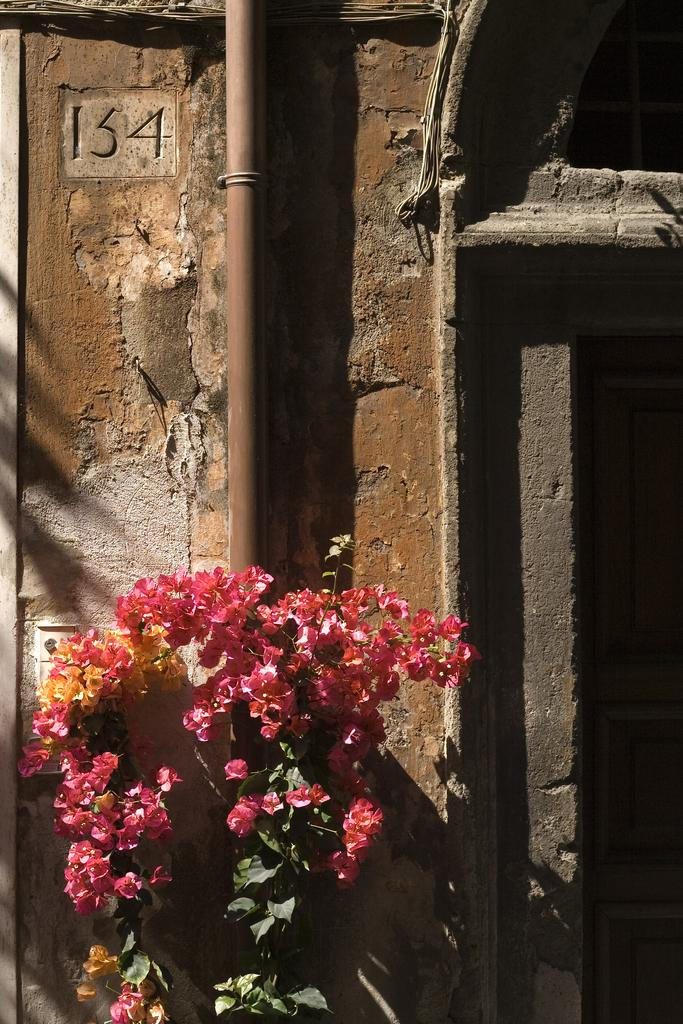What type of plant is in the image? There is a flower plant in the image. What other object can be seen in the image? There is a pipe in the image. What is visible in the background of the image? The wall is visible in the background of the image. Where is the monkey sitting in the image? There is no monkey present in the image. What type of land is visible in the image? The image does not depict any land; it features a flower plant, a pipe, and a wall. 